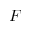Convert formula to latex. <formula><loc_0><loc_0><loc_500><loc_500>F</formula> 